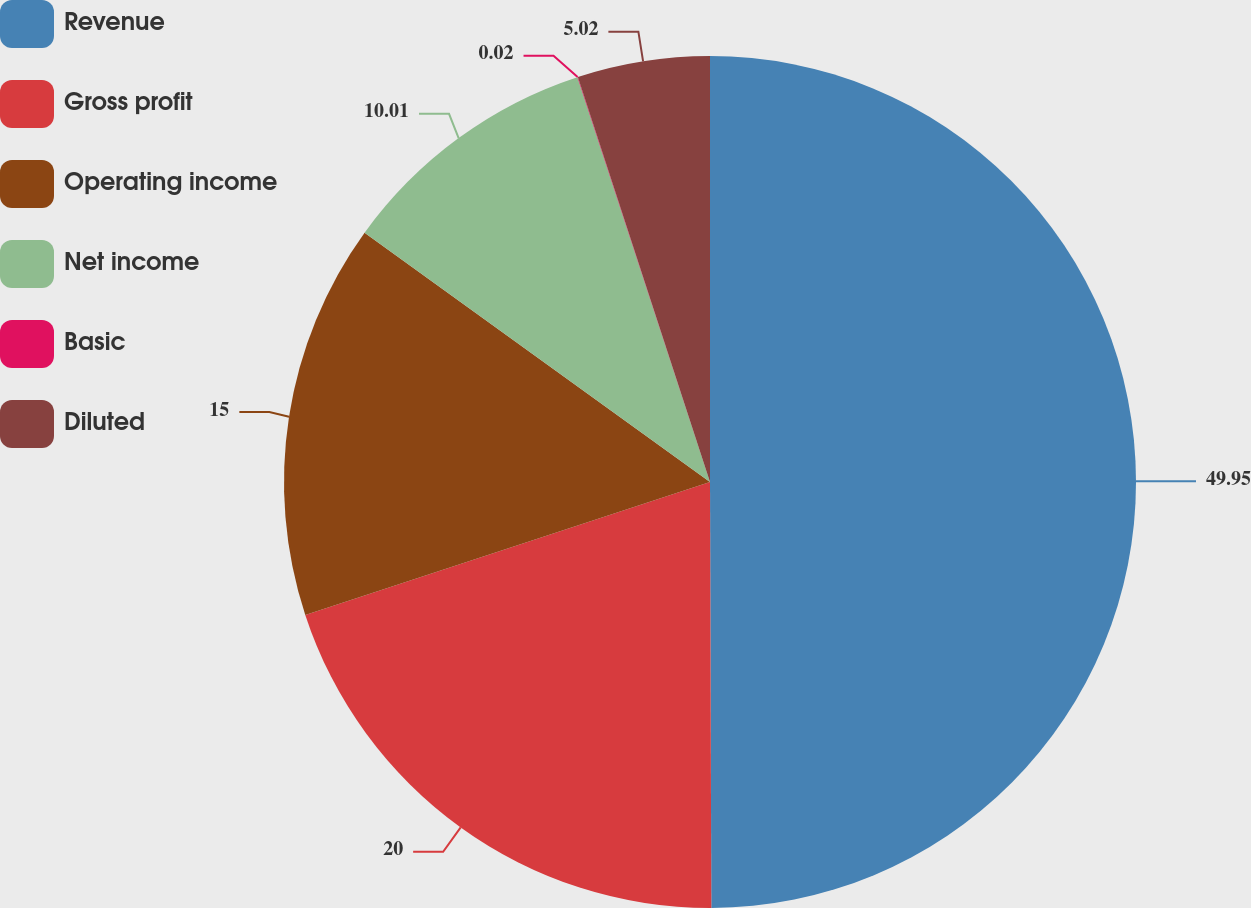<chart> <loc_0><loc_0><loc_500><loc_500><pie_chart><fcel>Revenue<fcel>Gross profit<fcel>Operating income<fcel>Net income<fcel>Basic<fcel>Diluted<nl><fcel>49.95%<fcel>20.0%<fcel>15.0%<fcel>10.01%<fcel>0.02%<fcel>5.02%<nl></chart> 